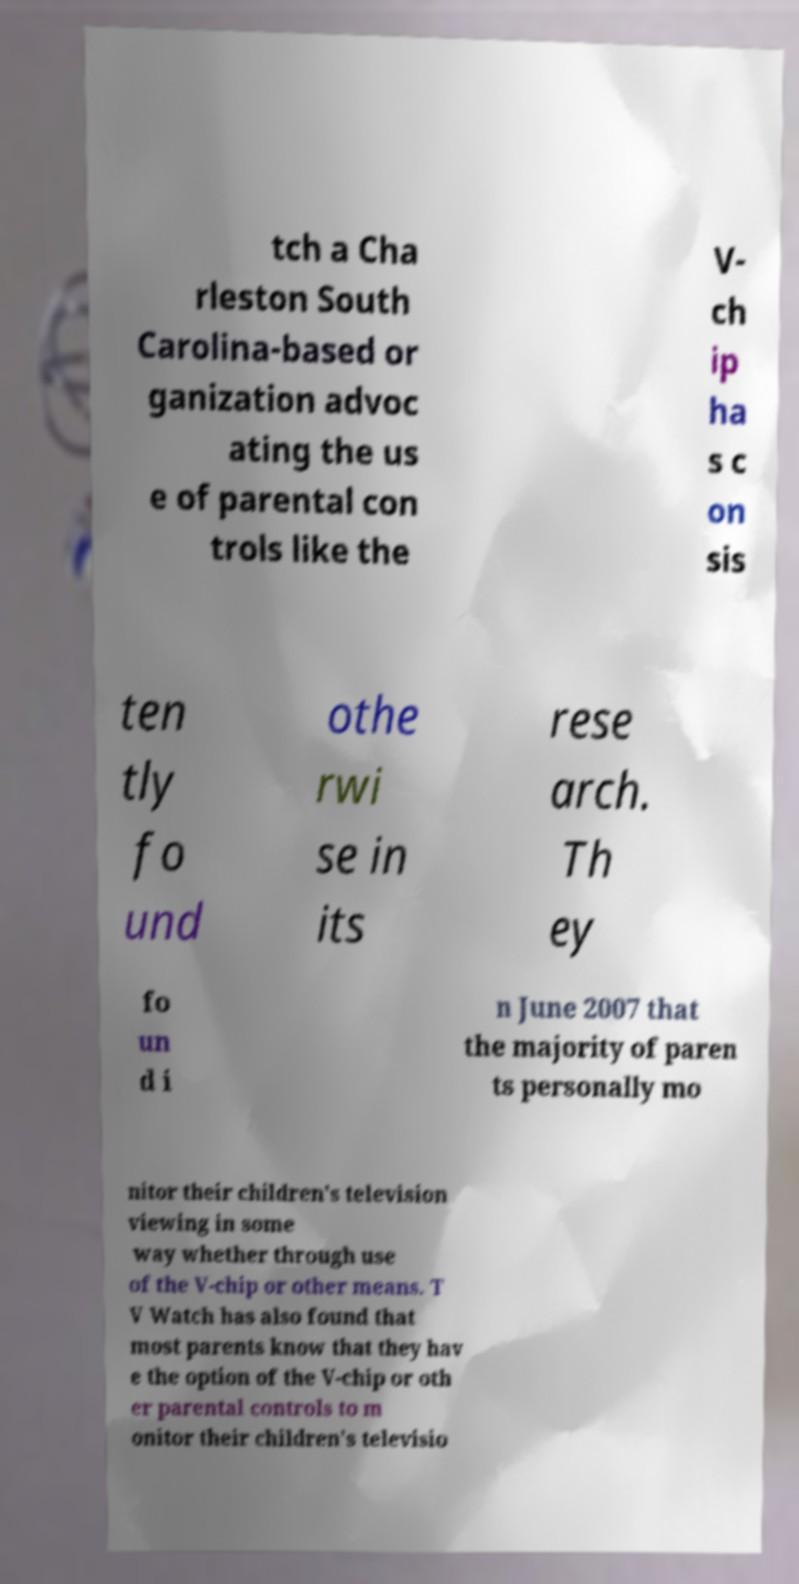What messages or text are displayed in this image? I need them in a readable, typed format. tch a Cha rleston South Carolina-based or ganization advoc ating the us e of parental con trols like the V- ch ip ha s c on sis ten tly fo und othe rwi se in its rese arch. Th ey fo un d i n June 2007 that the majority of paren ts personally mo nitor their children's television viewing in some way whether through use of the V-chip or other means. T V Watch has also found that most parents know that they hav e the option of the V-chip or oth er parental controls to m onitor their children's televisio 